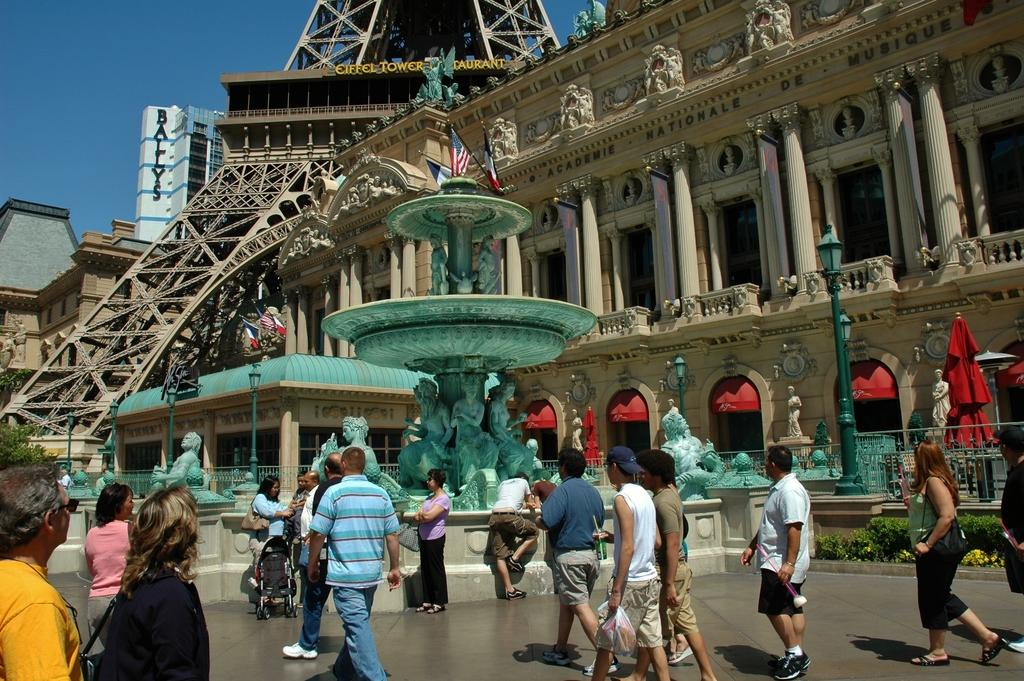What is located in the foreground of the image? There are people in the foreground of the image. What can be seen in the background of the image? There are buildings, pillars, a tower, a fountain, a flag, and the sky visible in the background of the image. Can you describe the architectural features in the background of the image? There are pillars and a tower visible in the background of the image. What natural element is visible in the background of the image? The sky is visible in the background of the image. What type of book is being read by the person wearing a mask in the image? There is no person wearing a mask or reading a book in the image. What impulse is being displayed by the people in the image? The image does not show any specific impulses or emotions of the people; they are simply standing in the foreground. 